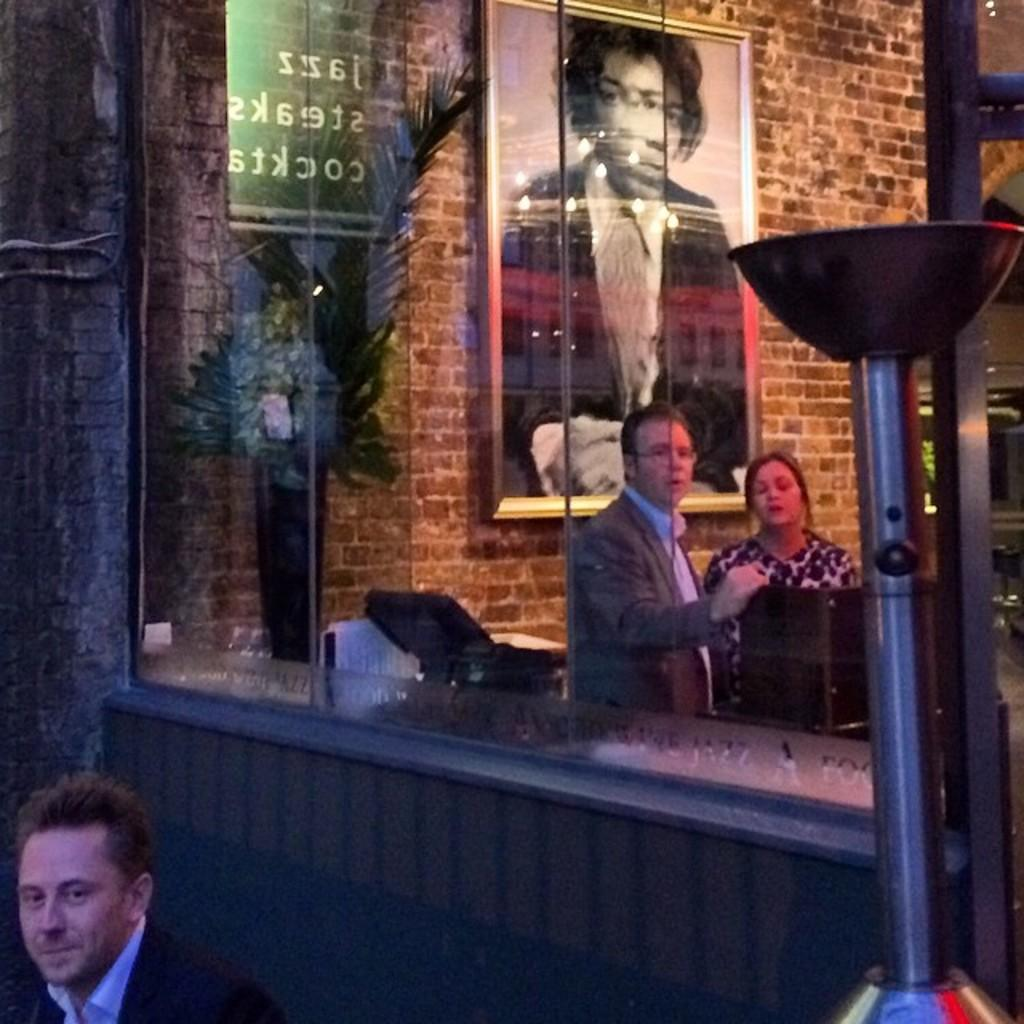How many people are present in the image? There are three persons in the image. What objects can be seen in the image besides the people? There are glasses, a plant, a pole, and a frame visible in the image. What is the background of the image? There is a wall in the background of the image. What type of lettuce is growing on the pole in the image? There is no lettuce present in the image, and the pole does not have any plants growing on it. 